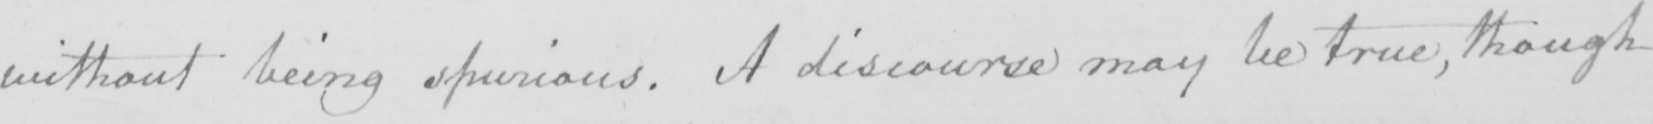Can you read and transcribe this handwriting? without being spurious . A discourse may be true , though 